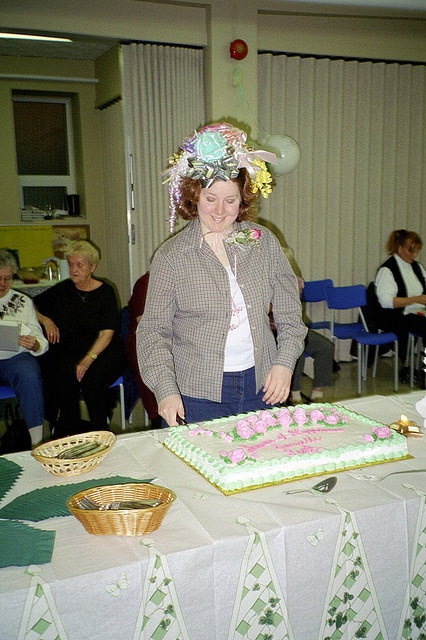Describe the objects in this image and their specific colors. I can see dining table in darkgreen, lightgray, darkgray, and beige tones, people in darkgreen, darkgray, lightgray, tan, and gray tones, cake in darkgreen, ivory, beige, lightgreen, and lightpink tones, people in darkgreen, black, olive, and gray tones, and people in darkgreen, black, darkgray, gray, and navy tones in this image. 